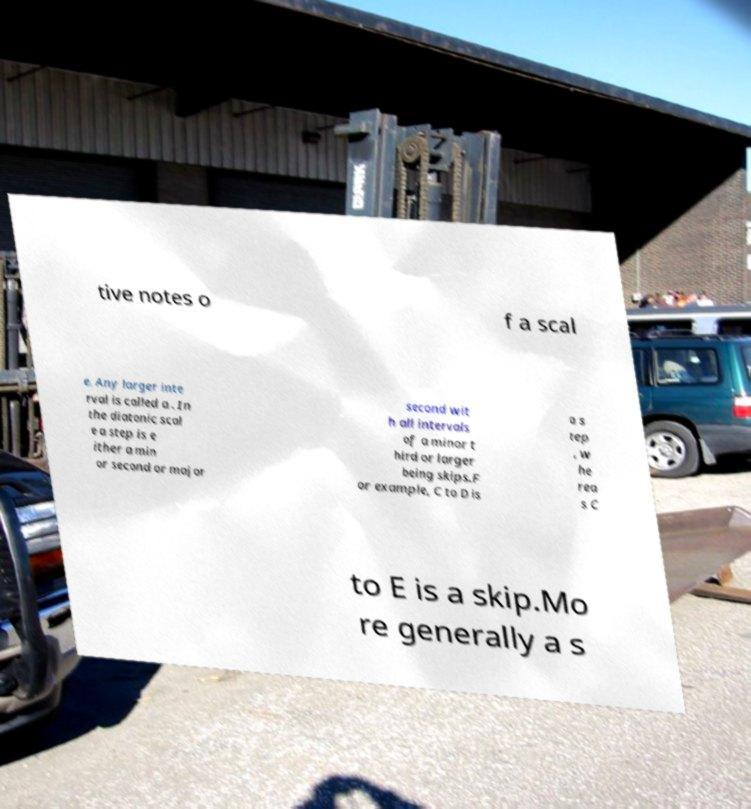Please identify and transcribe the text found in this image. tive notes o f a scal e. Any larger inte rval is called a . In the diatonic scal e a step is e ither a min or second or major second wit h all intervals of a minor t hird or larger being skips.F or example, C to D is a s tep , w he rea s C to E is a skip.Mo re generally a s 